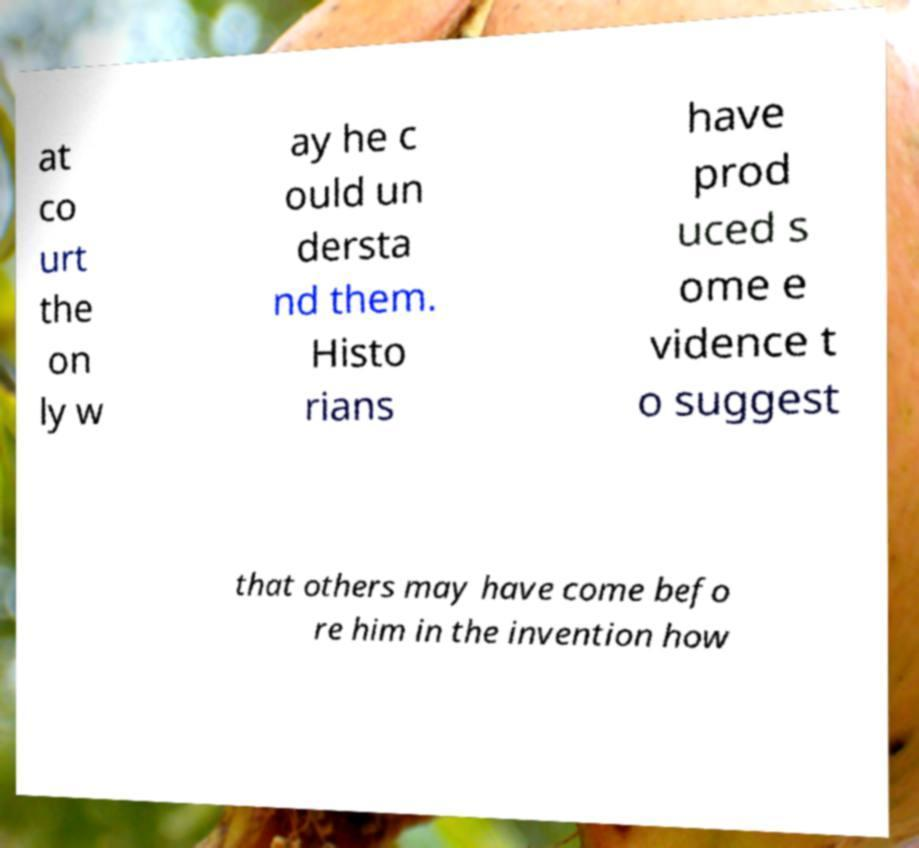Can you read and provide the text displayed in the image?This photo seems to have some interesting text. Can you extract and type it out for me? at co urt the on ly w ay he c ould un dersta nd them. Histo rians have prod uced s ome e vidence t o suggest that others may have come befo re him in the invention how 